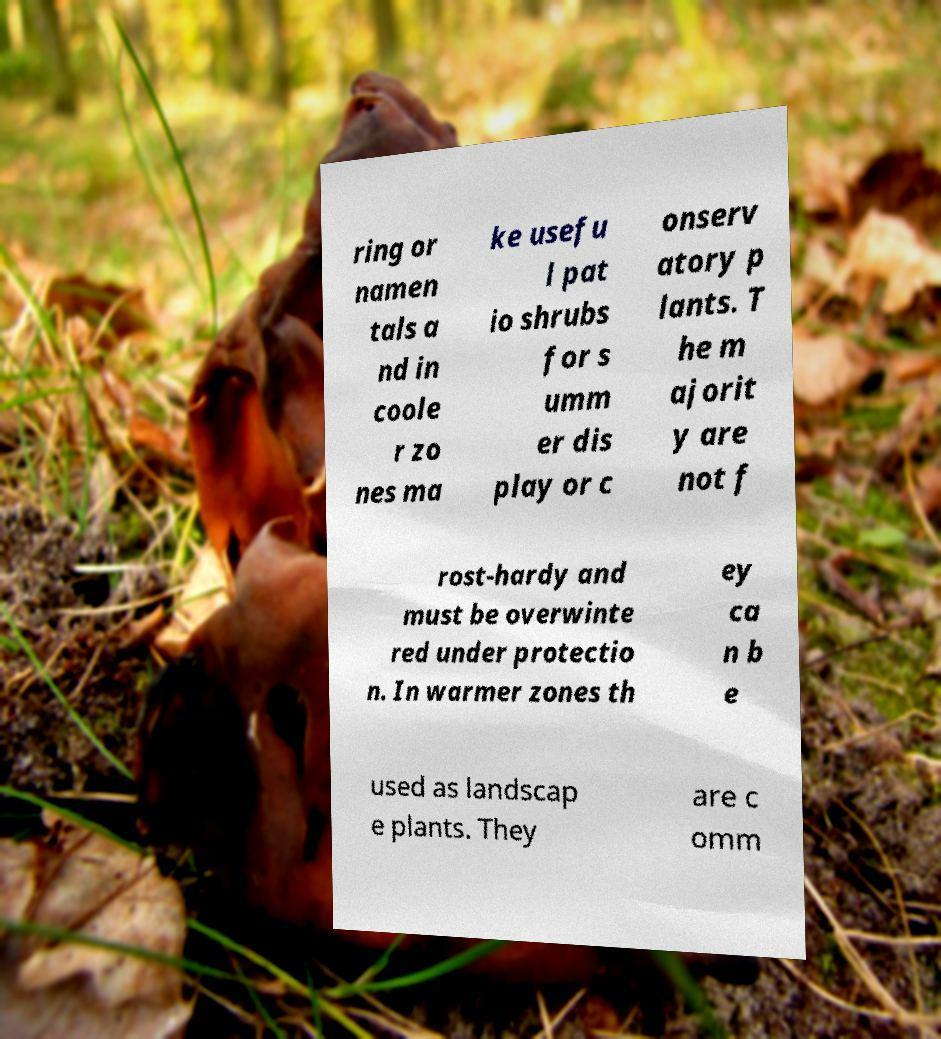Can you read and provide the text displayed in the image?This photo seems to have some interesting text. Can you extract and type it out for me? ring or namen tals a nd in coole r zo nes ma ke usefu l pat io shrubs for s umm er dis play or c onserv atory p lants. T he m ajorit y are not f rost-hardy and must be overwinte red under protectio n. In warmer zones th ey ca n b e used as landscap e plants. They are c omm 